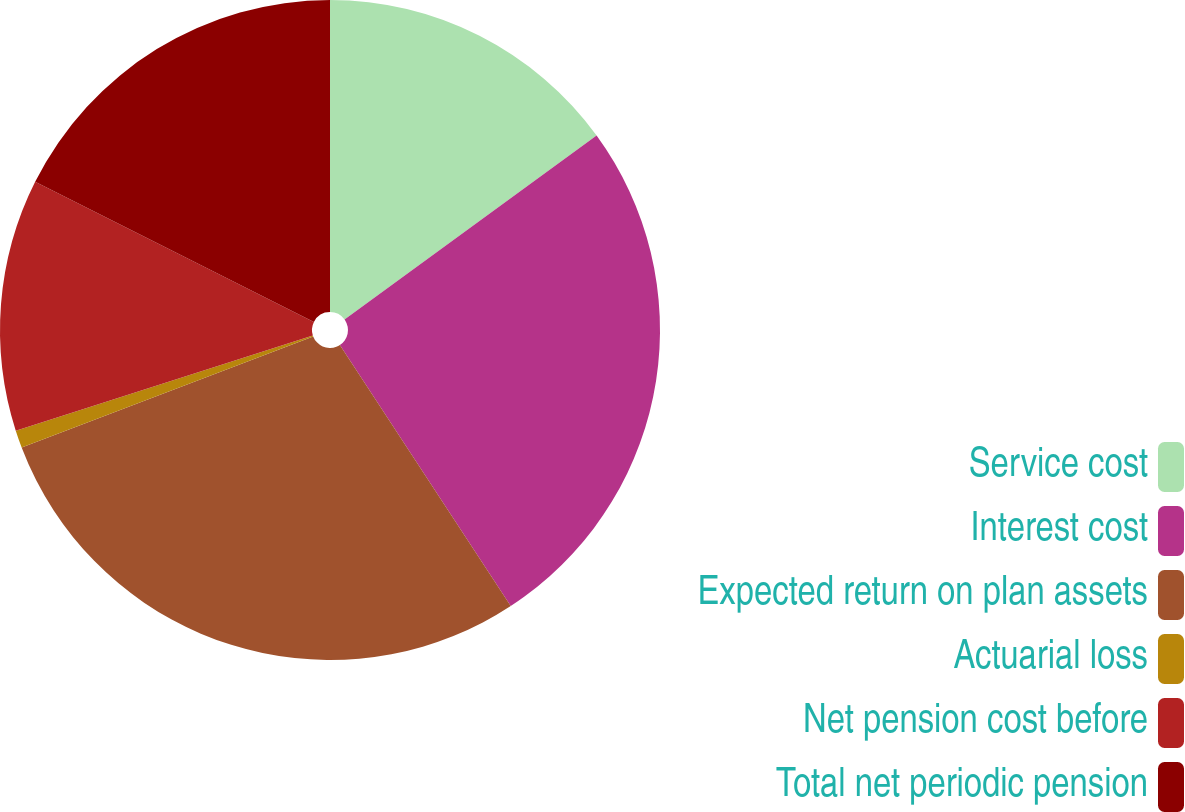Convert chart to OTSL. <chart><loc_0><loc_0><loc_500><loc_500><pie_chart><fcel>Service cost<fcel>Interest cost<fcel>Expected return on plan assets<fcel>Actuarial loss<fcel>Net pension cost before<fcel>Total net periodic pension<nl><fcel>14.97%<fcel>25.81%<fcel>28.43%<fcel>0.86%<fcel>12.35%<fcel>17.59%<nl></chart> 